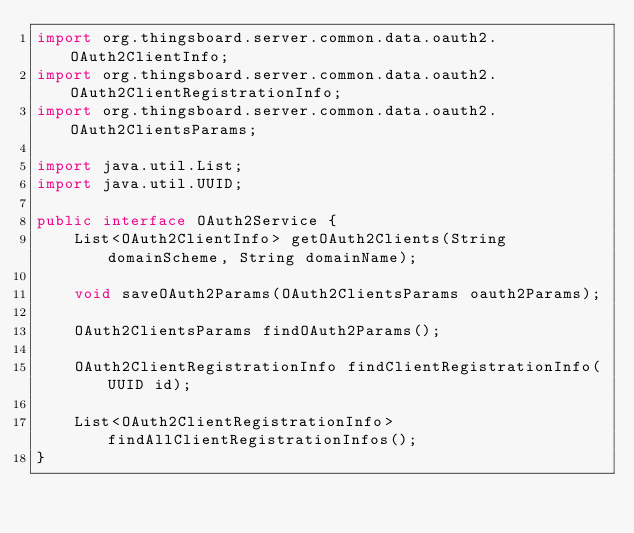<code> <loc_0><loc_0><loc_500><loc_500><_Java_>import org.thingsboard.server.common.data.oauth2.OAuth2ClientInfo;
import org.thingsboard.server.common.data.oauth2.OAuth2ClientRegistrationInfo;
import org.thingsboard.server.common.data.oauth2.OAuth2ClientsParams;

import java.util.List;
import java.util.UUID;

public interface OAuth2Service {
    List<OAuth2ClientInfo> getOAuth2Clients(String domainScheme, String domainName);

    void saveOAuth2Params(OAuth2ClientsParams oauth2Params);

    OAuth2ClientsParams findOAuth2Params();

    OAuth2ClientRegistrationInfo findClientRegistrationInfo(UUID id);

    List<OAuth2ClientRegistrationInfo> findAllClientRegistrationInfos();
}
</code> 